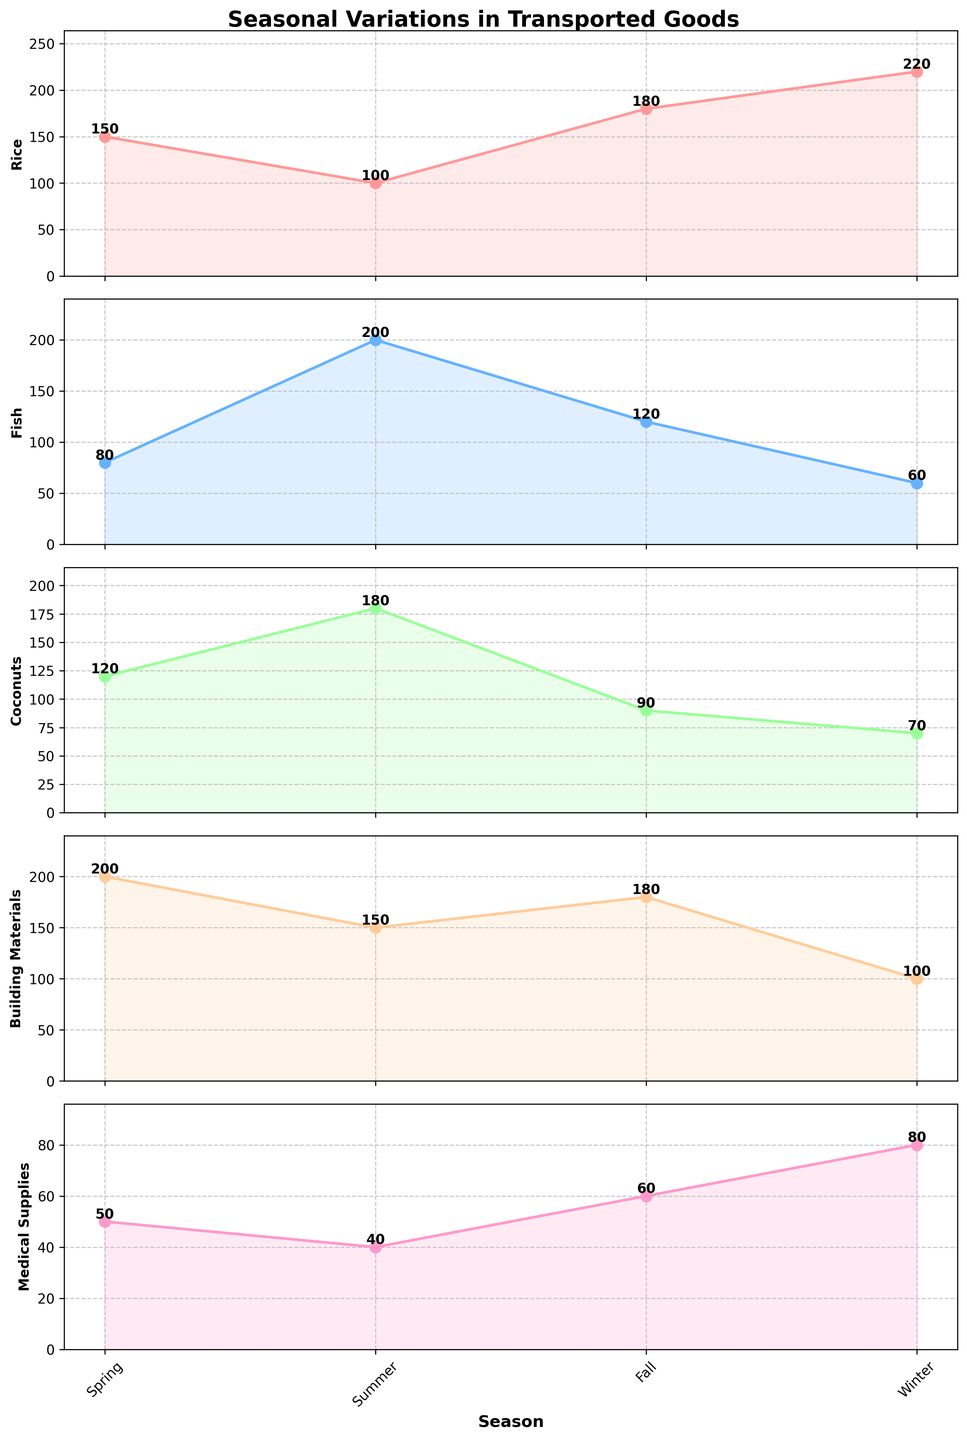How many seasons are represented in the figure? The x-axis shows the different seasons, which can be counted directly from the figure.
Answer: 4 What is the title of the figure? The title is usually displayed at the top of the figure.
Answer: Seasonal Variations in Transported Goods Which transported good has the highest demand in Winter? To find this, you need to look at the vertical subplot for each good and find the highest value for Winter.
Answer: Rice Is the demand for Medical Supplies higher in Fall or Spring? Compare the values for Medical Supplies in Fall and Spring from the corresponding subplot.
Answer: Fall What is the average demand for Fish throughout the seasons? Add the demand values for Fish across all seasons and then divide by the number of seasons (4). (80 + 200 + 120 + 60) / 4 = 115
Answer: 115 Which season has the lowest demand for Coconuts? Look at the subplot for Coconuts and find the lowest value among the seasons.
Answer: Winter How does the demand for Building Materials in Summer compare to that in Winter? Check the values for Building Materials in both Summer and Winter to see which one is higher.
Answer: Summer (150 vs. 100) Which transported good shows the most variation in demand across the seasons? Identify the good with the largest range between its highest and lowest values. Fish has a range of 200 - 60 = 140.
Answer: Fish What is the total demand for goods in Spring? Sum the values for all goods in Spring. 150 + 80 + 120 + 200 + 50 = 600
Answer: 600 Which goods have their highest demand in Spring? Check each subplot and identify which ones peak in Spring.
Answer: Building Materials, Coconuts 